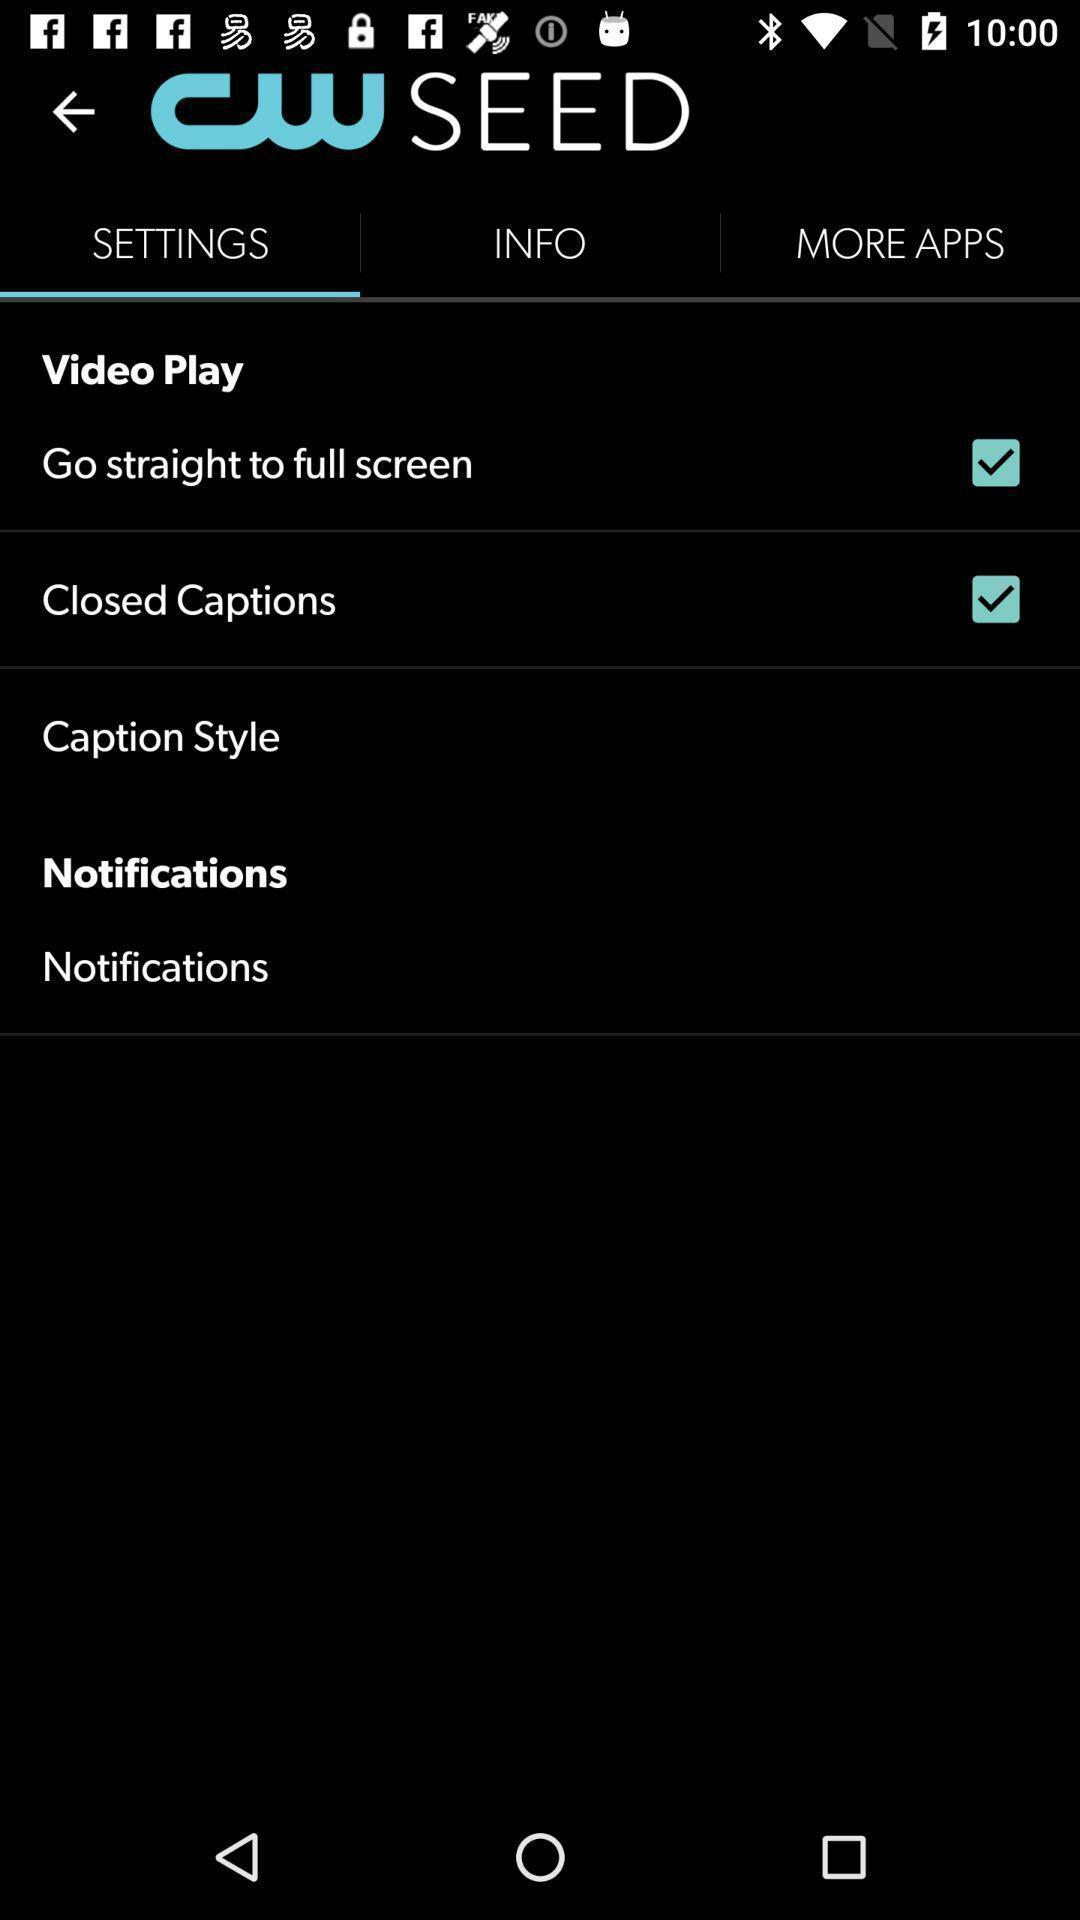Provide a textual representation of this image. Screen showing settings options. 